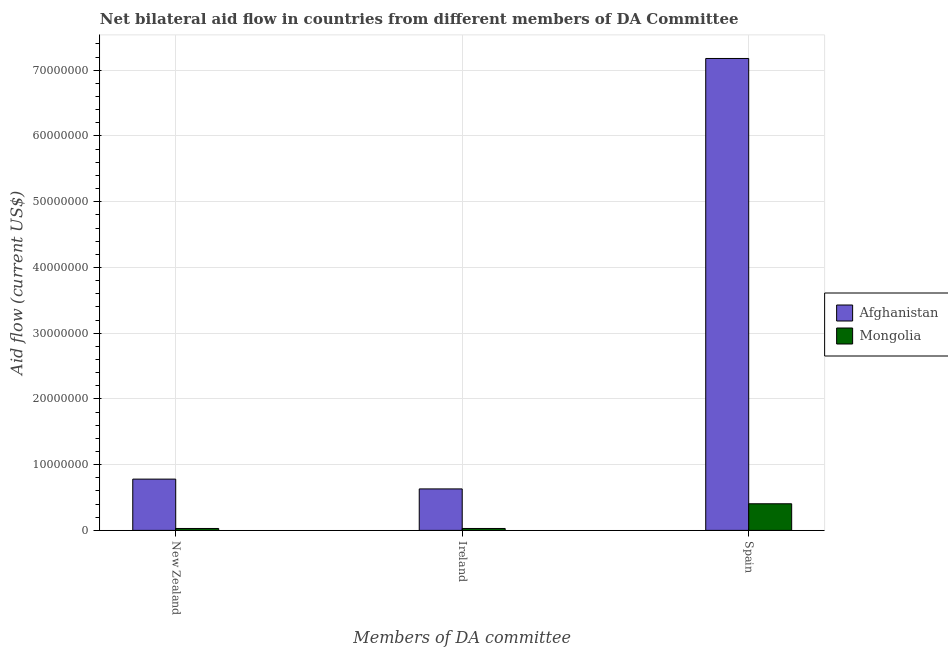How many groups of bars are there?
Keep it short and to the point. 3. Are the number of bars per tick equal to the number of legend labels?
Give a very brief answer. Yes. Are the number of bars on each tick of the X-axis equal?
Provide a short and direct response. Yes. How many bars are there on the 2nd tick from the left?
Your response must be concise. 2. What is the label of the 2nd group of bars from the left?
Your response must be concise. Ireland. What is the amount of aid provided by ireland in Afghanistan?
Give a very brief answer. 6.31e+06. Across all countries, what is the maximum amount of aid provided by new zealand?
Offer a terse response. 7.80e+06. Across all countries, what is the minimum amount of aid provided by ireland?
Make the answer very short. 2.90e+05. In which country was the amount of aid provided by new zealand maximum?
Your answer should be very brief. Afghanistan. In which country was the amount of aid provided by ireland minimum?
Provide a succinct answer. Mongolia. What is the total amount of aid provided by ireland in the graph?
Provide a succinct answer. 6.60e+06. What is the difference between the amount of aid provided by spain in Mongolia and that in Afghanistan?
Offer a terse response. -6.77e+07. What is the difference between the amount of aid provided by new zealand in Mongolia and the amount of aid provided by spain in Afghanistan?
Provide a succinct answer. -7.15e+07. What is the average amount of aid provided by new zealand per country?
Keep it short and to the point. 4.04e+06. What is the difference between the amount of aid provided by spain and amount of aid provided by ireland in Mongolia?
Your answer should be compact. 3.76e+06. What is the ratio of the amount of aid provided by ireland in Mongolia to that in Afghanistan?
Make the answer very short. 0.05. Is the amount of aid provided by spain in Afghanistan less than that in Mongolia?
Ensure brevity in your answer.  No. What is the difference between the highest and the second highest amount of aid provided by spain?
Give a very brief answer. 6.77e+07. What is the difference between the highest and the lowest amount of aid provided by ireland?
Keep it short and to the point. 6.02e+06. What does the 1st bar from the left in New Zealand represents?
Provide a succinct answer. Afghanistan. What does the 2nd bar from the right in Ireland represents?
Your answer should be compact. Afghanistan. How many bars are there?
Offer a very short reply. 6. Are all the bars in the graph horizontal?
Give a very brief answer. No. What is the difference between two consecutive major ticks on the Y-axis?
Give a very brief answer. 1.00e+07. Are the values on the major ticks of Y-axis written in scientific E-notation?
Give a very brief answer. No. Does the graph contain grids?
Make the answer very short. Yes. Where does the legend appear in the graph?
Make the answer very short. Center right. How many legend labels are there?
Provide a short and direct response. 2. How are the legend labels stacked?
Offer a very short reply. Vertical. What is the title of the graph?
Your answer should be very brief. Net bilateral aid flow in countries from different members of DA Committee. What is the label or title of the X-axis?
Provide a succinct answer. Members of DA committee. What is the label or title of the Y-axis?
Make the answer very short. Aid flow (current US$). What is the Aid flow (current US$) of Afghanistan in New Zealand?
Your answer should be compact. 7.80e+06. What is the Aid flow (current US$) in Mongolia in New Zealand?
Your answer should be compact. 2.90e+05. What is the Aid flow (current US$) of Afghanistan in Ireland?
Keep it short and to the point. 6.31e+06. What is the Aid flow (current US$) of Mongolia in Ireland?
Your response must be concise. 2.90e+05. What is the Aid flow (current US$) of Afghanistan in Spain?
Make the answer very short. 7.18e+07. What is the Aid flow (current US$) in Mongolia in Spain?
Your answer should be very brief. 4.05e+06. Across all Members of DA committee, what is the maximum Aid flow (current US$) in Afghanistan?
Ensure brevity in your answer.  7.18e+07. Across all Members of DA committee, what is the maximum Aid flow (current US$) of Mongolia?
Make the answer very short. 4.05e+06. Across all Members of DA committee, what is the minimum Aid flow (current US$) in Afghanistan?
Give a very brief answer. 6.31e+06. Across all Members of DA committee, what is the minimum Aid flow (current US$) of Mongolia?
Provide a succinct answer. 2.90e+05. What is the total Aid flow (current US$) of Afghanistan in the graph?
Your response must be concise. 8.59e+07. What is the total Aid flow (current US$) in Mongolia in the graph?
Offer a very short reply. 4.63e+06. What is the difference between the Aid flow (current US$) of Afghanistan in New Zealand and that in Ireland?
Keep it short and to the point. 1.49e+06. What is the difference between the Aid flow (current US$) of Afghanistan in New Zealand and that in Spain?
Your response must be concise. -6.40e+07. What is the difference between the Aid flow (current US$) in Mongolia in New Zealand and that in Spain?
Provide a succinct answer. -3.76e+06. What is the difference between the Aid flow (current US$) of Afghanistan in Ireland and that in Spain?
Make the answer very short. -6.55e+07. What is the difference between the Aid flow (current US$) in Mongolia in Ireland and that in Spain?
Provide a short and direct response. -3.76e+06. What is the difference between the Aid flow (current US$) of Afghanistan in New Zealand and the Aid flow (current US$) of Mongolia in Ireland?
Make the answer very short. 7.51e+06. What is the difference between the Aid flow (current US$) in Afghanistan in New Zealand and the Aid flow (current US$) in Mongolia in Spain?
Your answer should be very brief. 3.75e+06. What is the difference between the Aid flow (current US$) of Afghanistan in Ireland and the Aid flow (current US$) of Mongolia in Spain?
Give a very brief answer. 2.26e+06. What is the average Aid flow (current US$) in Afghanistan per Members of DA committee?
Your response must be concise. 2.86e+07. What is the average Aid flow (current US$) of Mongolia per Members of DA committee?
Offer a very short reply. 1.54e+06. What is the difference between the Aid flow (current US$) of Afghanistan and Aid flow (current US$) of Mongolia in New Zealand?
Give a very brief answer. 7.51e+06. What is the difference between the Aid flow (current US$) of Afghanistan and Aid flow (current US$) of Mongolia in Ireland?
Your answer should be very brief. 6.02e+06. What is the difference between the Aid flow (current US$) in Afghanistan and Aid flow (current US$) in Mongolia in Spain?
Ensure brevity in your answer.  6.77e+07. What is the ratio of the Aid flow (current US$) of Afghanistan in New Zealand to that in Ireland?
Offer a very short reply. 1.24. What is the ratio of the Aid flow (current US$) of Afghanistan in New Zealand to that in Spain?
Make the answer very short. 0.11. What is the ratio of the Aid flow (current US$) in Mongolia in New Zealand to that in Spain?
Your answer should be compact. 0.07. What is the ratio of the Aid flow (current US$) in Afghanistan in Ireland to that in Spain?
Your response must be concise. 0.09. What is the ratio of the Aid flow (current US$) in Mongolia in Ireland to that in Spain?
Your response must be concise. 0.07. What is the difference between the highest and the second highest Aid flow (current US$) of Afghanistan?
Make the answer very short. 6.40e+07. What is the difference between the highest and the second highest Aid flow (current US$) of Mongolia?
Your response must be concise. 3.76e+06. What is the difference between the highest and the lowest Aid flow (current US$) of Afghanistan?
Provide a succinct answer. 6.55e+07. What is the difference between the highest and the lowest Aid flow (current US$) of Mongolia?
Give a very brief answer. 3.76e+06. 